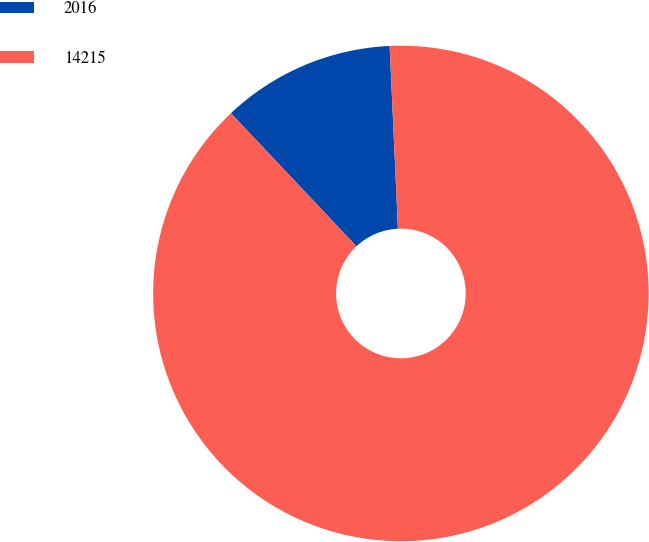<chart> <loc_0><loc_0><loc_500><loc_500><pie_chart><fcel>2016<fcel>14215<nl><fcel>11.31%<fcel>88.69%<nl></chart> 